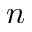Convert formula to latex. <formula><loc_0><loc_0><loc_500><loc_500>n</formula> 